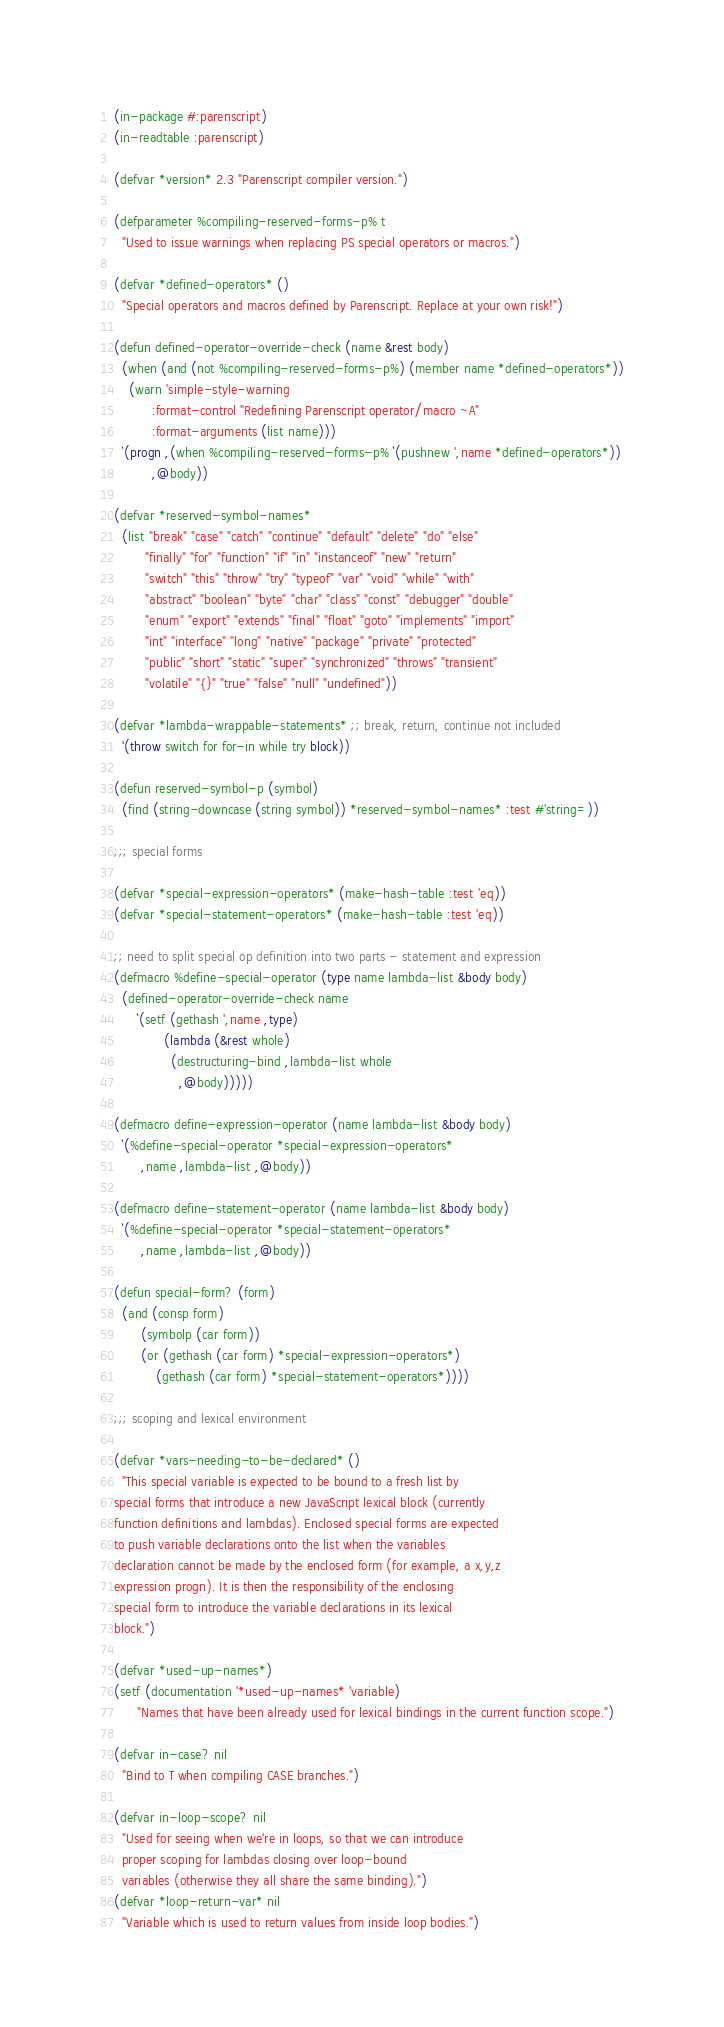<code> <loc_0><loc_0><loc_500><loc_500><_Lisp_>(in-package #:parenscript)
(in-readtable :parenscript)

(defvar *version* 2.3 "Parenscript compiler version.")

(defparameter %compiling-reserved-forms-p% t
  "Used to issue warnings when replacing PS special operators or macros.")

(defvar *defined-operators* ()
  "Special operators and macros defined by Parenscript. Replace at your own risk!")

(defun defined-operator-override-check (name &rest body)
  (when (and (not %compiling-reserved-forms-p%) (member name *defined-operators*))
    (warn 'simple-style-warning
          :format-control "Redefining Parenscript operator/macro ~A"
          :format-arguments (list name)))
  `(progn ,(when %compiling-reserved-forms-p% `(pushnew ',name *defined-operators*))
          ,@body))

(defvar *reserved-symbol-names*
  (list "break" "case" "catch" "continue" "default" "delete" "do" "else"
        "finally" "for" "function" "if" "in" "instanceof" "new" "return"
        "switch" "this" "throw" "try" "typeof" "var" "void" "while" "with"
        "abstract" "boolean" "byte" "char" "class" "const" "debugger" "double"
        "enum" "export" "extends" "final" "float" "goto" "implements" "import"
        "int" "interface" "long" "native" "package" "private" "protected"
        "public" "short" "static" "super" "synchronized" "throws" "transient"
        "volatile" "{}" "true" "false" "null" "undefined"))

(defvar *lambda-wrappable-statements* ;; break, return, continue not included
  '(throw switch for for-in while try block))

(defun reserved-symbol-p (symbol)
  (find (string-downcase (string symbol)) *reserved-symbol-names* :test #'string=))

;;; special forms

(defvar *special-expression-operators* (make-hash-table :test 'eq))
(defvar *special-statement-operators* (make-hash-table :test 'eq))

;; need to split special op definition into two parts - statement and expression
(defmacro %define-special-operator (type name lambda-list &body body)
  (defined-operator-override-check name
      `(setf (gethash ',name ,type)
             (lambda (&rest whole)
               (destructuring-bind ,lambda-list whole
                 ,@body)))))

(defmacro define-expression-operator (name lambda-list &body body)
  `(%define-special-operator *special-expression-operators*
       ,name ,lambda-list ,@body))

(defmacro define-statement-operator (name lambda-list &body body)
  `(%define-special-operator *special-statement-operators*
       ,name ,lambda-list ,@body))

(defun special-form? (form)
  (and (consp form)
       (symbolp (car form))
       (or (gethash (car form) *special-expression-operators*)
           (gethash (car form) *special-statement-operators*))))

;;; scoping and lexical environment

(defvar *vars-needing-to-be-declared* ()
  "This special variable is expected to be bound to a fresh list by
special forms that introduce a new JavaScript lexical block (currently
function definitions and lambdas). Enclosed special forms are expected
to push variable declarations onto the list when the variables
declaration cannot be made by the enclosed form (for example, a x,y,z
expression progn). It is then the responsibility of the enclosing
special form to introduce the variable declarations in its lexical
block.")

(defvar *used-up-names*)
(setf (documentation '*used-up-names* 'variable)
      "Names that have been already used for lexical bindings in the current function scope.")

(defvar in-case? nil
  "Bind to T when compiling CASE branches.")

(defvar in-loop-scope? nil
  "Used for seeing when we're in loops, so that we can introduce
  proper scoping for lambdas closing over loop-bound
  variables (otherwise they all share the same binding).")
(defvar *loop-return-var* nil
  "Variable which is used to return values from inside loop bodies.")</code> 